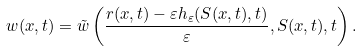Convert formula to latex. <formula><loc_0><loc_0><loc_500><loc_500>w ( x , t ) = \tilde { w } \left ( \frac { r ( x , t ) - \varepsilon h _ { \varepsilon } ( S ( x , t ) , t ) } { \varepsilon } , S ( x , t ) , t \right ) .</formula> 